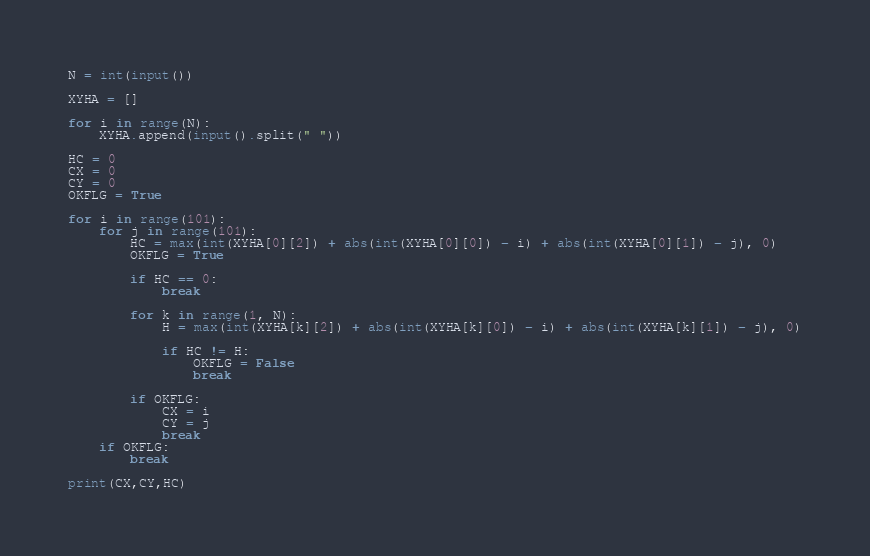Convert code to text. <code><loc_0><loc_0><loc_500><loc_500><_Python_>N = int(input())
 
XYHA = []
 
for i in range(N):
    XYHA.append(input().split(" "))
 
HC = 0
CX = 0
CY = 0
OKFLG = True
 
for i in range(101):
    for j in range(101):
        HC = max(int(XYHA[0][2]) + abs(int(XYHA[0][0]) - i) + abs(int(XYHA[0][1]) - j), 0)
        OKFLG = True

        if HC == 0:
            break

        for k in range(1, N):
            H = max(int(XYHA[k][2]) + abs(int(XYHA[k][0]) - i) + abs(int(XYHA[k][1]) - j), 0)
 
            if HC != H:
                OKFLG = False
                break
 
        if OKFLG:
            CX = i
            CY = j
            break
    if OKFLG:
        break
 
print(CX,CY,HC)</code> 